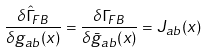<formula> <loc_0><loc_0><loc_500><loc_500>\frac { \delta \hat { \Gamma } _ { F B } } { \delta g _ { a b } ( x ) } = \frac { \delta \Gamma _ { F B } } { \delta \bar { g } _ { a b } ( x ) } = J _ { a b } ( x )</formula> 